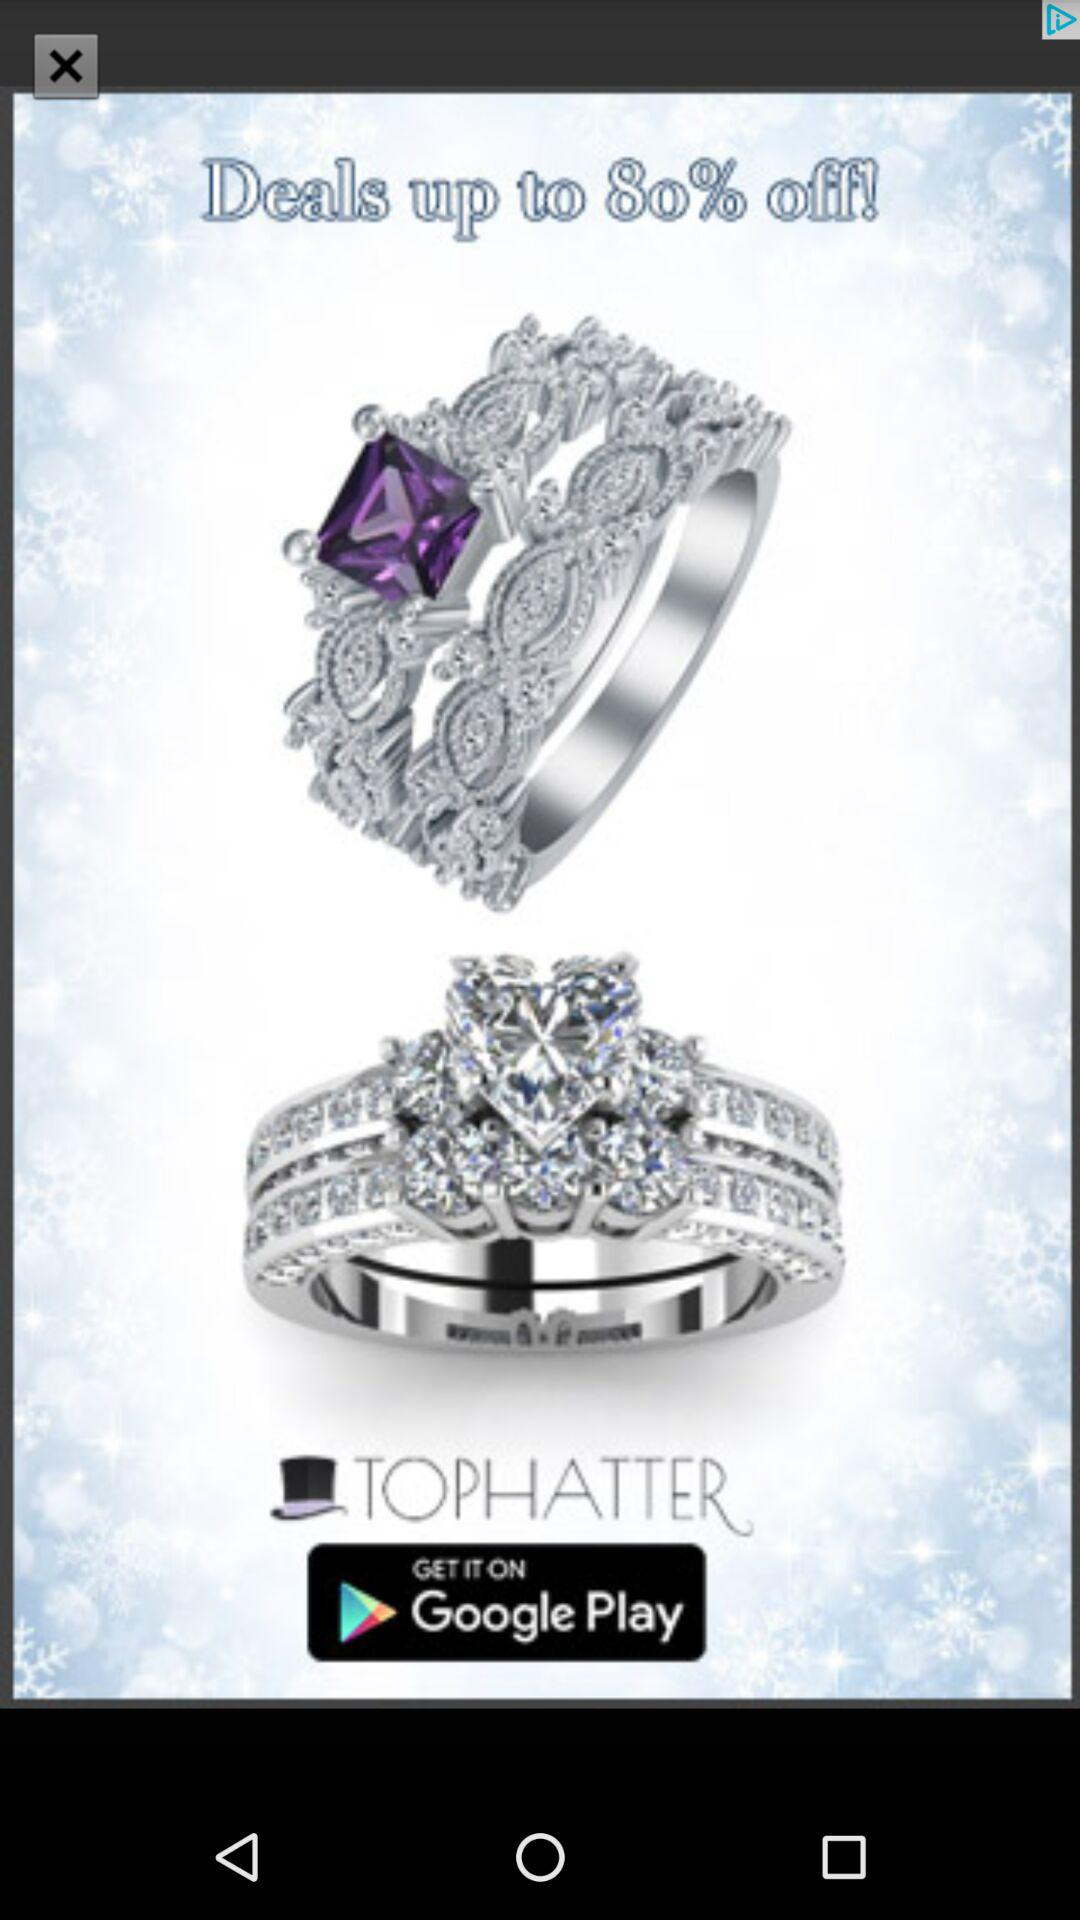Up to what percent of the discount can be availed on the deals? The discount that can be availed on the deals is up to 80%. 